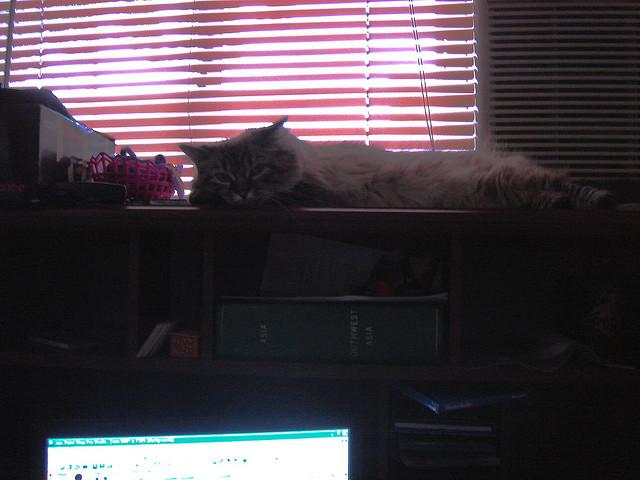Are the blinds open or closed?
Short answer required. Closed. Does the cat look active?
Concise answer only. No. What is the cat laying on?
Answer briefly. Desk. 